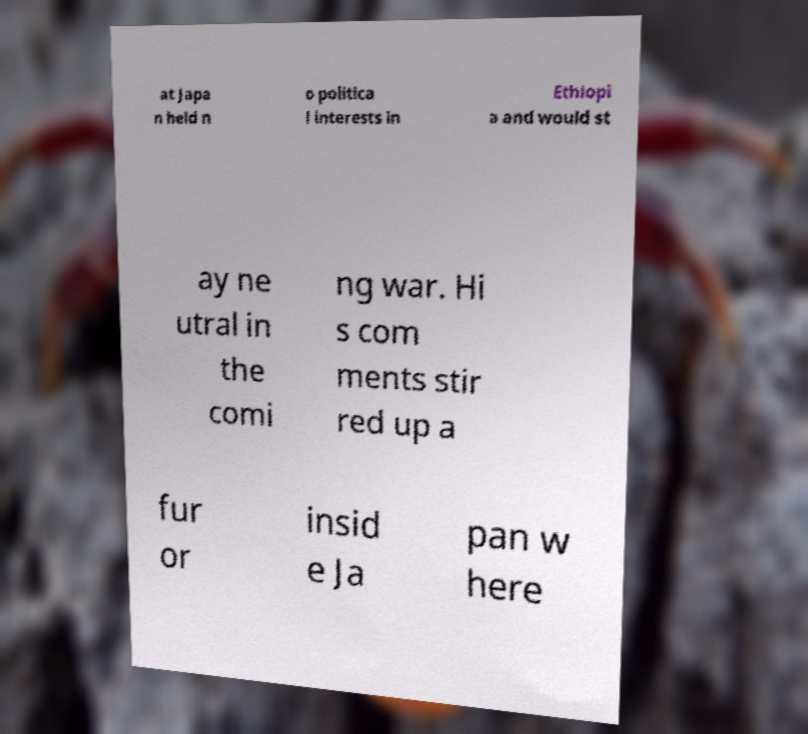For documentation purposes, I need the text within this image transcribed. Could you provide that? at Japa n held n o politica l interests in Ethiopi a and would st ay ne utral in the comi ng war. Hi s com ments stir red up a fur or insid e Ja pan w here 